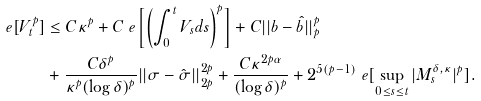Convert formula to latex. <formula><loc_0><loc_0><loc_500><loc_500>\ e [ V _ { t } ^ { p } ] & \leq C \kappa ^ { p } + C \ e \left [ \left ( \int _ { 0 } ^ { t } V _ { s } d s \right ) ^ { p } \right ] + C | | b - \hat { b } | | _ { p } ^ { p } \\ & + \frac { C \delta ^ { p } } { \kappa ^ { p } ( \log \delta ) ^ { p } } | | \sigma - \hat { \sigma } | | _ { 2 p } ^ { 2 p } + \frac { C \kappa ^ { 2 p \alpha } } { ( \log \delta ) ^ { p } } + 2 ^ { 5 ( p - 1 ) } \ e [ \sup _ { 0 \leq s \leq t } | M _ { s } ^ { \delta , \kappa } | ^ { p } ] .</formula> 